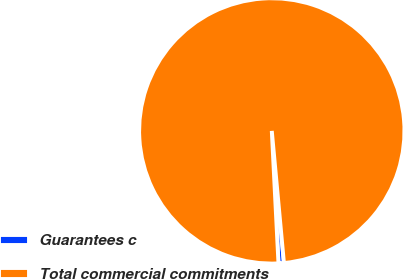Convert chart. <chart><loc_0><loc_0><loc_500><loc_500><pie_chart><fcel>Guarantees c<fcel>Total commercial commitments<nl><fcel>0.66%<fcel>99.34%<nl></chart> 